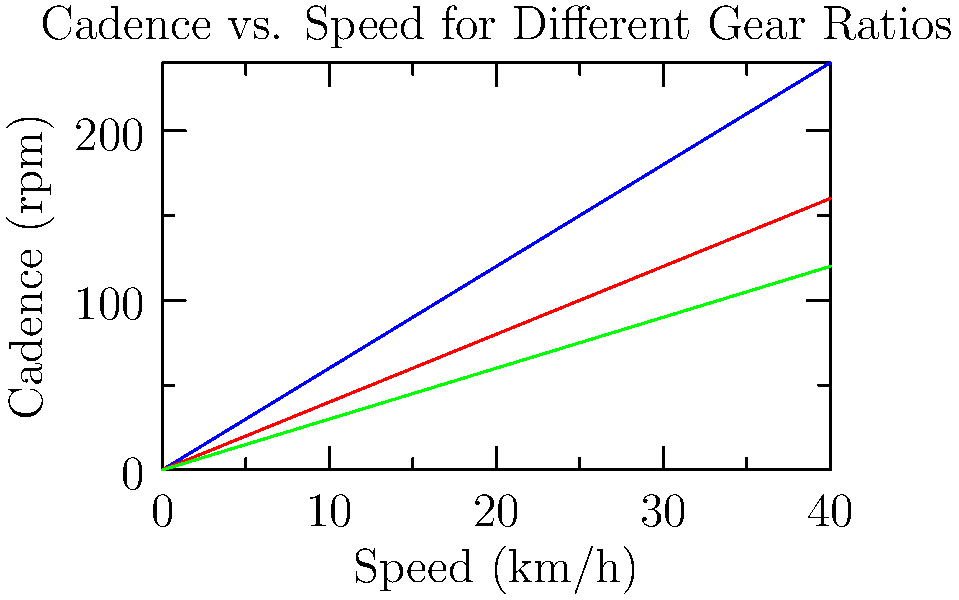As the cycling club president, you're planning a group ride on a flat route with an average speed of 25 km/h. Using the graph, which gear ratio would you recommend to maintain a comfortable cadence of about 90 rpm for most riders? To determine the optimal gear ratio for the given conditions, we need to follow these steps:

1. Identify the target speed: 25 km/h
2. Identify the target cadence: 90 rpm
3. Examine the graph to find which gear ratio line passes closest to the intersection of 25 km/h and 90 rpm

Analyzing the graph:

1. The blue line (Gear Ratio 1:1) shows a cadence of about 150 rpm at 25 km/h, which is too high.
2. The red line (Gear Ratio 1.5:1) shows a cadence of about 100 rpm at 25 km/h, which is close to our target of 90 rpm.
3. The green line (Gear Ratio 2:1) shows a cadence of about 75 rpm at 25 km/h, which is lower than our target.

The red line (Gear Ratio 1.5:1) provides the closest match to our desired cadence of 90 rpm at 25 km/h.
Answer: Gear Ratio 1.5:1 